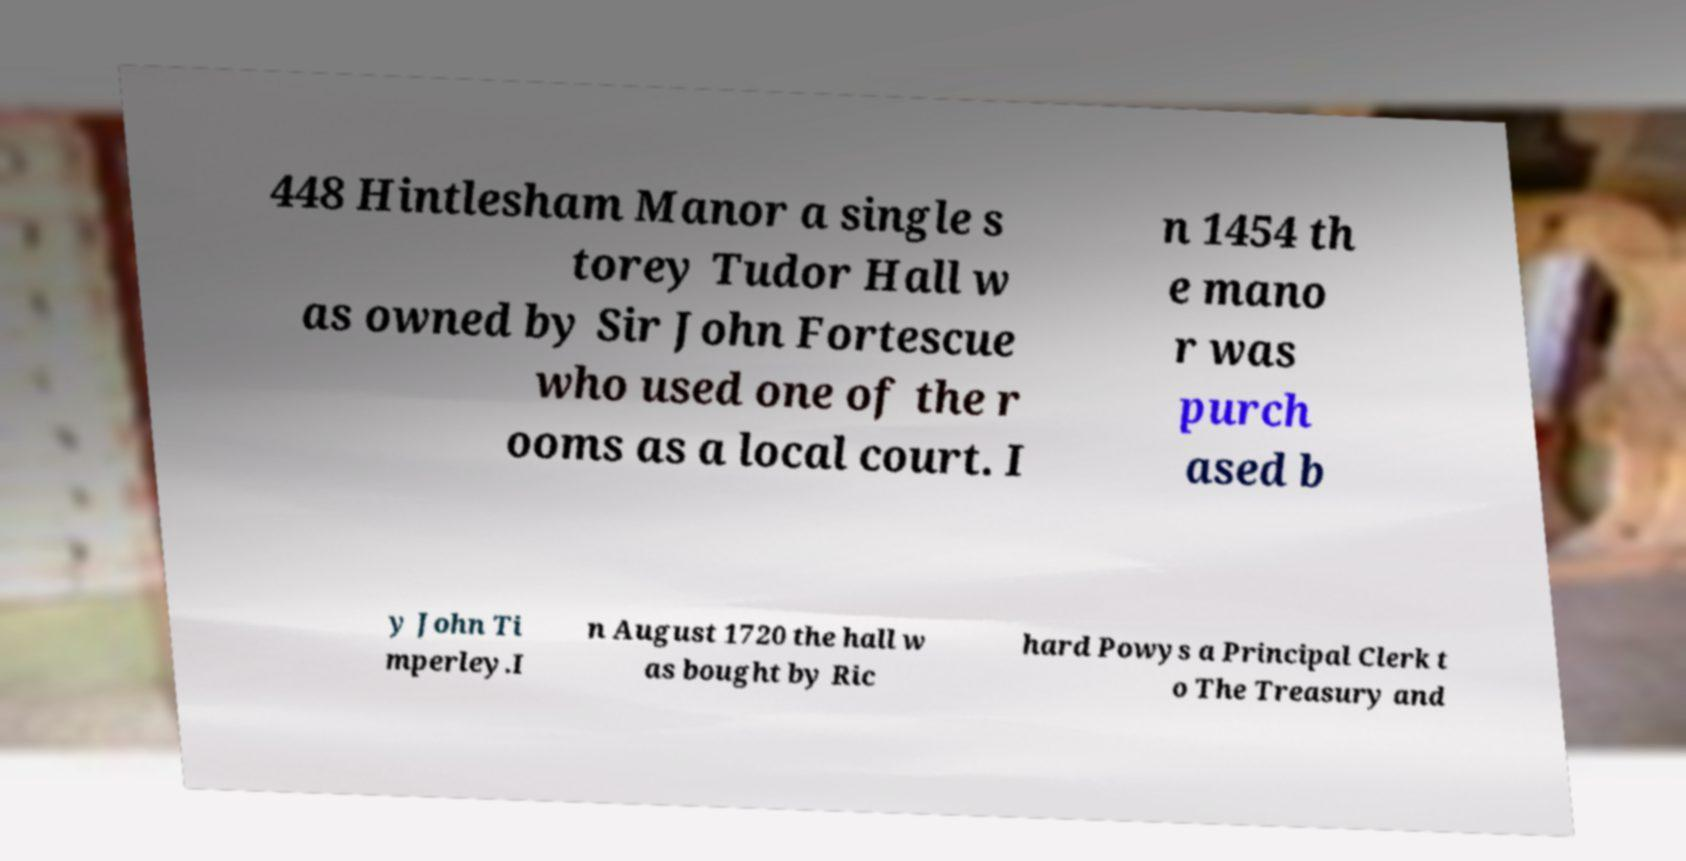I need the written content from this picture converted into text. Can you do that? 448 Hintlesham Manor a single s torey Tudor Hall w as owned by Sir John Fortescue who used one of the r ooms as a local court. I n 1454 th e mano r was purch ased b y John Ti mperley.I n August 1720 the hall w as bought by Ric hard Powys a Principal Clerk t o The Treasury and 